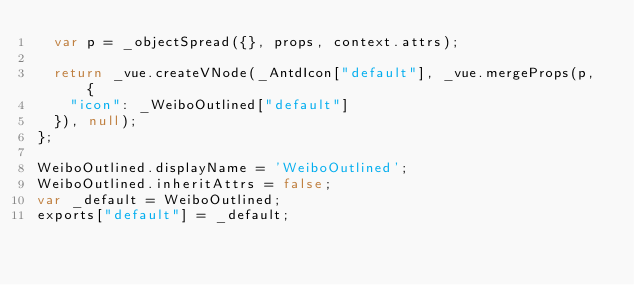Convert code to text. <code><loc_0><loc_0><loc_500><loc_500><_JavaScript_>  var p = _objectSpread({}, props, context.attrs);

  return _vue.createVNode(_AntdIcon["default"], _vue.mergeProps(p, {
    "icon": _WeiboOutlined["default"]
  }), null);
};

WeiboOutlined.displayName = 'WeiboOutlined';
WeiboOutlined.inheritAttrs = false;
var _default = WeiboOutlined;
exports["default"] = _default;</code> 